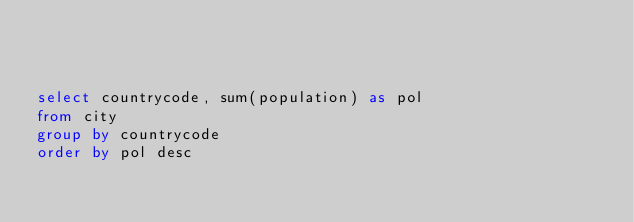<code> <loc_0><loc_0><loc_500><loc_500><_SQL_>


select countrycode, sum(population) as pol
from city
group by countrycode
order by pol desc
</code> 